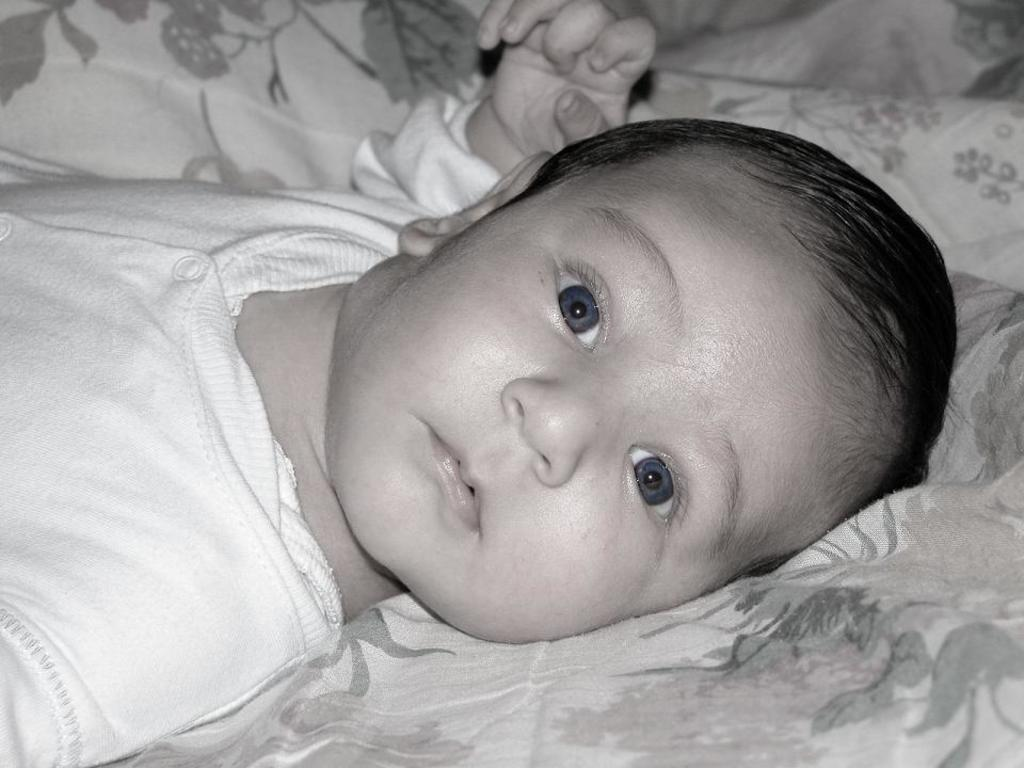What is the main subject of the image? There is a baby in the image. Where is the baby located? The baby is on a bed. What type of beetle can be seen crawling on the baby in the image? There is no beetle present in the image; it only features a baby on a bed. How many quarters can be seen on the bed next to the baby? There are no quarters visible in the image; it only features a baby on a bed. 